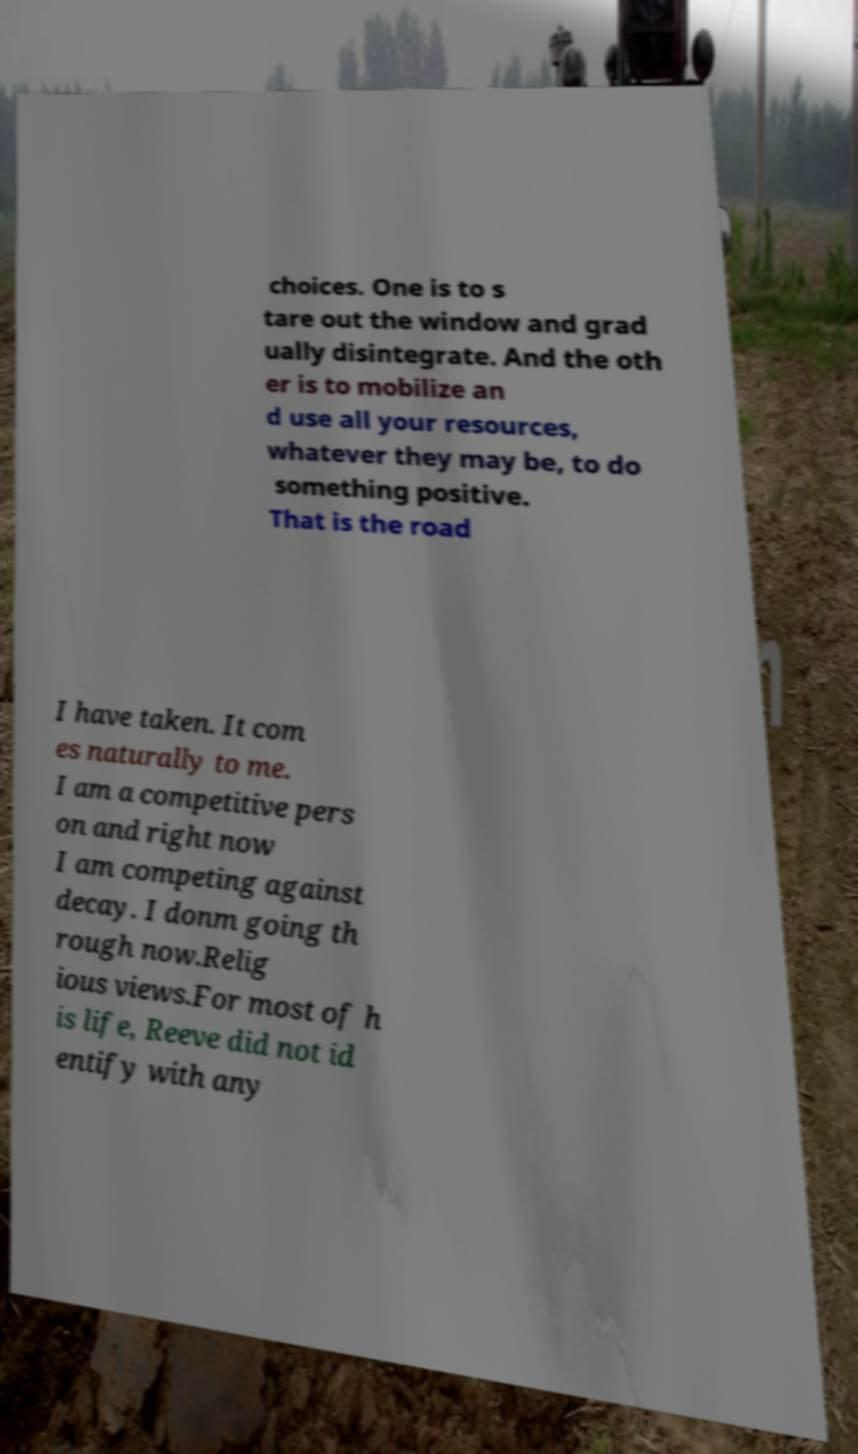Please read and relay the text visible in this image. What does it say? choices. One is to s tare out the window and grad ually disintegrate. And the oth er is to mobilize an d use all your resources, whatever they may be, to do something positive. That is the road I have taken. It com es naturally to me. I am a competitive pers on and right now I am competing against decay. I donm going th rough now.Relig ious views.For most of h is life, Reeve did not id entify with any 